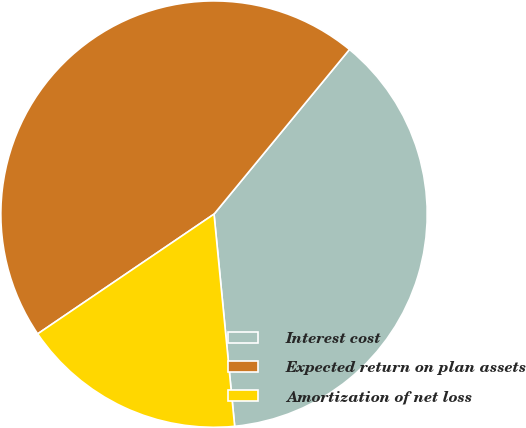Convert chart to OTSL. <chart><loc_0><loc_0><loc_500><loc_500><pie_chart><fcel>Interest cost<fcel>Expected return on plan assets<fcel>Amortization of net loss<nl><fcel>37.5%<fcel>45.45%<fcel>17.05%<nl></chart> 